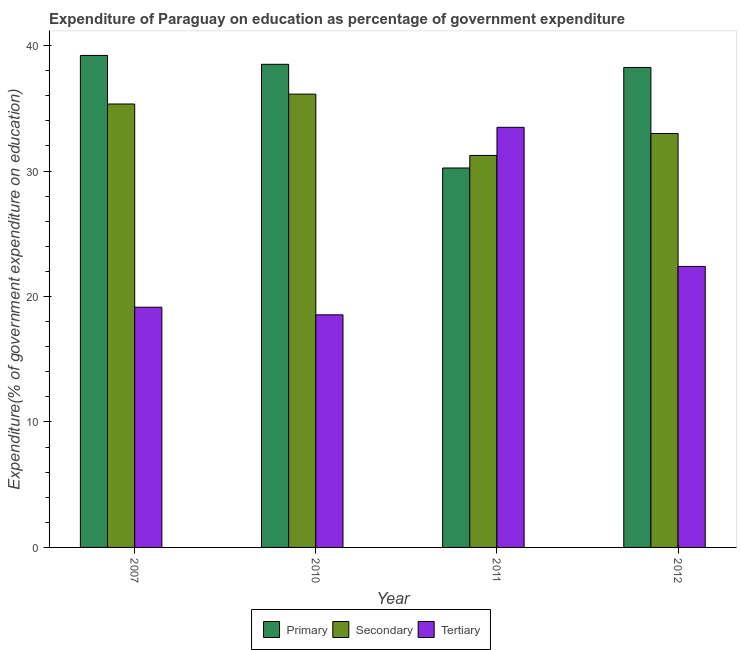How many different coloured bars are there?
Offer a very short reply. 3. Are the number of bars on each tick of the X-axis equal?
Your answer should be compact. Yes. How many bars are there on the 4th tick from the left?
Offer a terse response. 3. How many bars are there on the 4th tick from the right?
Your answer should be very brief. 3. What is the expenditure on primary education in 2011?
Your response must be concise. 30.24. Across all years, what is the maximum expenditure on primary education?
Keep it short and to the point. 39.21. Across all years, what is the minimum expenditure on secondary education?
Your answer should be very brief. 31.24. In which year was the expenditure on tertiary education maximum?
Your response must be concise. 2011. What is the total expenditure on primary education in the graph?
Keep it short and to the point. 146.22. What is the difference between the expenditure on primary education in 2007 and that in 2010?
Your answer should be compact. 0.71. What is the difference between the expenditure on primary education in 2011 and the expenditure on secondary education in 2012?
Your answer should be compact. -8.01. What is the average expenditure on tertiary education per year?
Your response must be concise. 23.39. What is the ratio of the expenditure on secondary education in 2007 to that in 2012?
Offer a terse response. 1.07. What is the difference between the highest and the second highest expenditure on tertiary education?
Provide a succinct answer. 11.09. What is the difference between the highest and the lowest expenditure on tertiary education?
Make the answer very short. 14.95. In how many years, is the expenditure on tertiary education greater than the average expenditure on tertiary education taken over all years?
Offer a terse response. 1. What does the 1st bar from the left in 2007 represents?
Offer a terse response. Primary. What does the 2nd bar from the right in 2007 represents?
Give a very brief answer. Secondary. Is it the case that in every year, the sum of the expenditure on primary education and expenditure on secondary education is greater than the expenditure on tertiary education?
Make the answer very short. Yes. Are all the bars in the graph horizontal?
Ensure brevity in your answer.  No. How many years are there in the graph?
Keep it short and to the point. 4. What is the difference between two consecutive major ticks on the Y-axis?
Your response must be concise. 10. Are the values on the major ticks of Y-axis written in scientific E-notation?
Ensure brevity in your answer.  No. Does the graph contain grids?
Ensure brevity in your answer.  No. Where does the legend appear in the graph?
Your answer should be compact. Bottom center. How many legend labels are there?
Offer a terse response. 3. How are the legend labels stacked?
Your response must be concise. Horizontal. What is the title of the graph?
Offer a terse response. Expenditure of Paraguay on education as percentage of government expenditure. Does "Oil" appear as one of the legend labels in the graph?
Make the answer very short. No. What is the label or title of the Y-axis?
Your answer should be very brief. Expenditure(% of government expenditure on education). What is the Expenditure(% of government expenditure on education) of Primary in 2007?
Offer a very short reply. 39.21. What is the Expenditure(% of government expenditure on education) in Secondary in 2007?
Give a very brief answer. 35.34. What is the Expenditure(% of government expenditure on education) of Tertiary in 2007?
Your response must be concise. 19.15. What is the Expenditure(% of government expenditure on education) of Primary in 2010?
Your answer should be compact. 38.51. What is the Expenditure(% of government expenditure on education) of Secondary in 2010?
Give a very brief answer. 36.13. What is the Expenditure(% of government expenditure on education) of Tertiary in 2010?
Offer a terse response. 18.54. What is the Expenditure(% of government expenditure on education) in Primary in 2011?
Provide a short and direct response. 30.24. What is the Expenditure(% of government expenditure on education) in Secondary in 2011?
Your answer should be very brief. 31.24. What is the Expenditure(% of government expenditure on education) of Tertiary in 2011?
Your answer should be compact. 33.48. What is the Expenditure(% of government expenditure on education) of Primary in 2012?
Keep it short and to the point. 38.25. What is the Expenditure(% of government expenditure on education) of Secondary in 2012?
Make the answer very short. 32.99. What is the Expenditure(% of government expenditure on education) of Tertiary in 2012?
Keep it short and to the point. 22.4. Across all years, what is the maximum Expenditure(% of government expenditure on education) in Primary?
Make the answer very short. 39.21. Across all years, what is the maximum Expenditure(% of government expenditure on education) of Secondary?
Your response must be concise. 36.13. Across all years, what is the maximum Expenditure(% of government expenditure on education) of Tertiary?
Provide a short and direct response. 33.48. Across all years, what is the minimum Expenditure(% of government expenditure on education) of Primary?
Offer a terse response. 30.24. Across all years, what is the minimum Expenditure(% of government expenditure on education) of Secondary?
Provide a short and direct response. 31.24. Across all years, what is the minimum Expenditure(% of government expenditure on education) in Tertiary?
Make the answer very short. 18.54. What is the total Expenditure(% of government expenditure on education) of Primary in the graph?
Make the answer very short. 146.22. What is the total Expenditure(% of government expenditure on education) in Secondary in the graph?
Offer a very short reply. 135.7. What is the total Expenditure(% of government expenditure on education) in Tertiary in the graph?
Ensure brevity in your answer.  93.57. What is the difference between the Expenditure(% of government expenditure on education) in Primary in 2007 and that in 2010?
Ensure brevity in your answer.  0.71. What is the difference between the Expenditure(% of government expenditure on education) in Secondary in 2007 and that in 2010?
Offer a very short reply. -0.79. What is the difference between the Expenditure(% of government expenditure on education) in Tertiary in 2007 and that in 2010?
Your answer should be compact. 0.61. What is the difference between the Expenditure(% of government expenditure on education) in Primary in 2007 and that in 2011?
Give a very brief answer. 8.97. What is the difference between the Expenditure(% of government expenditure on education) in Secondary in 2007 and that in 2011?
Your response must be concise. 4.1. What is the difference between the Expenditure(% of government expenditure on education) in Tertiary in 2007 and that in 2011?
Give a very brief answer. -14.34. What is the difference between the Expenditure(% of government expenditure on education) in Primary in 2007 and that in 2012?
Give a very brief answer. 0.96. What is the difference between the Expenditure(% of government expenditure on education) of Secondary in 2007 and that in 2012?
Offer a very short reply. 2.35. What is the difference between the Expenditure(% of government expenditure on education) of Tertiary in 2007 and that in 2012?
Provide a short and direct response. -3.25. What is the difference between the Expenditure(% of government expenditure on education) in Primary in 2010 and that in 2011?
Ensure brevity in your answer.  8.26. What is the difference between the Expenditure(% of government expenditure on education) in Secondary in 2010 and that in 2011?
Your answer should be compact. 4.89. What is the difference between the Expenditure(% of government expenditure on education) in Tertiary in 2010 and that in 2011?
Offer a terse response. -14.95. What is the difference between the Expenditure(% of government expenditure on education) of Primary in 2010 and that in 2012?
Your response must be concise. 0.25. What is the difference between the Expenditure(% of government expenditure on education) of Secondary in 2010 and that in 2012?
Your answer should be compact. 3.14. What is the difference between the Expenditure(% of government expenditure on education) in Tertiary in 2010 and that in 2012?
Give a very brief answer. -3.86. What is the difference between the Expenditure(% of government expenditure on education) in Primary in 2011 and that in 2012?
Give a very brief answer. -8.01. What is the difference between the Expenditure(% of government expenditure on education) in Secondary in 2011 and that in 2012?
Your answer should be very brief. -1.75. What is the difference between the Expenditure(% of government expenditure on education) in Tertiary in 2011 and that in 2012?
Your response must be concise. 11.09. What is the difference between the Expenditure(% of government expenditure on education) in Primary in 2007 and the Expenditure(% of government expenditure on education) in Secondary in 2010?
Keep it short and to the point. 3.08. What is the difference between the Expenditure(% of government expenditure on education) in Primary in 2007 and the Expenditure(% of government expenditure on education) in Tertiary in 2010?
Keep it short and to the point. 20.68. What is the difference between the Expenditure(% of government expenditure on education) in Secondary in 2007 and the Expenditure(% of government expenditure on education) in Tertiary in 2010?
Your answer should be compact. 16.8. What is the difference between the Expenditure(% of government expenditure on education) of Primary in 2007 and the Expenditure(% of government expenditure on education) of Secondary in 2011?
Provide a succinct answer. 7.97. What is the difference between the Expenditure(% of government expenditure on education) of Primary in 2007 and the Expenditure(% of government expenditure on education) of Tertiary in 2011?
Keep it short and to the point. 5.73. What is the difference between the Expenditure(% of government expenditure on education) in Secondary in 2007 and the Expenditure(% of government expenditure on education) in Tertiary in 2011?
Your answer should be compact. 1.86. What is the difference between the Expenditure(% of government expenditure on education) of Primary in 2007 and the Expenditure(% of government expenditure on education) of Secondary in 2012?
Offer a terse response. 6.22. What is the difference between the Expenditure(% of government expenditure on education) of Primary in 2007 and the Expenditure(% of government expenditure on education) of Tertiary in 2012?
Your answer should be very brief. 16.82. What is the difference between the Expenditure(% of government expenditure on education) in Secondary in 2007 and the Expenditure(% of government expenditure on education) in Tertiary in 2012?
Your response must be concise. 12.94. What is the difference between the Expenditure(% of government expenditure on education) in Primary in 2010 and the Expenditure(% of government expenditure on education) in Secondary in 2011?
Make the answer very short. 7.27. What is the difference between the Expenditure(% of government expenditure on education) of Primary in 2010 and the Expenditure(% of government expenditure on education) of Tertiary in 2011?
Your response must be concise. 5.02. What is the difference between the Expenditure(% of government expenditure on education) in Secondary in 2010 and the Expenditure(% of government expenditure on education) in Tertiary in 2011?
Provide a succinct answer. 2.65. What is the difference between the Expenditure(% of government expenditure on education) of Primary in 2010 and the Expenditure(% of government expenditure on education) of Secondary in 2012?
Provide a short and direct response. 5.51. What is the difference between the Expenditure(% of government expenditure on education) of Primary in 2010 and the Expenditure(% of government expenditure on education) of Tertiary in 2012?
Keep it short and to the point. 16.11. What is the difference between the Expenditure(% of government expenditure on education) in Secondary in 2010 and the Expenditure(% of government expenditure on education) in Tertiary in 2012?
Offer a terse response. 13.73. What is the difference between the Expenditure(% of government expenditure on education) of Primary in 2011 and the Expenditure(% of government expenditure on education) of Secondary in 2012?
Make the answer very short. -2.75. What is the difference between the Expenditure(% of government expenditure on education) of Primary in 2011 and the Expenditure(% of government expenditure on education) of Tertiary in 2012?
Your response must be concise. 7.84. What is the difference between the Expenditure(% of government expenditure on education) of Secondary in 2011 and the Expenditure(% of government expenditure on education) of Tertiary in 2012?
Provide a short and direct response. 8.84. What is the average Expenditure(% of government expenditure on education) in Primary per year?
Offer a very short reply. 36.55. What is the average Expenditure(% of government expenditure on education) in Secondary per year?
Offer a very short reply. 33.93. What is the average Expenditure(% of government expenditure on education) of Tertiary per year?
Give a very brief answer. 23.39. In the year 2007, what is the difference between the Expenditure(% of government expenditure on education) of Primary and Expenditure(% of government expenditure on education) of Secondary?
Ensure brevity in your answer.  3.87. In the year 2007, what is the difference between the Expenditure(% of government expenditure on education) of Primary and Expenditure(% of government expenditure on education) of Tertiary?
Make the answer very short. 20.07. In the year 2007, what is the difference between the Expenditure(% of government expenditure on education) of Secondary and Expenditure(% of government expenditure on education) of Tertiary?
Provide a succinct answer. 16.2. In the year 2010, what is the difference between the Expenditure(% of government expenditure on education) in Primary and Expenditure(% of government expenditure on education) in Secondary?
Your answer should be very brief. 2.38. In the year 2010, what is the difference between the Expenditure(% of government expenditure on education) in Primary and Expenditure(% of government expenditure on education) in Tertiary?
Ensure brevity in your answer.  19.97. In the year 2010, what is the difference between the Expenditure(% of government expenditure on education) in Secondary and Expenditure(% of government expenditure on education) in Tertiary?
Your answer should be very brief. 17.59. In the year 2011, what is the difference between the Expenditure(% of government expenditure on education) in Primary and Expenditure(% of government expenditure on education) in Secondary?
Provide a succinct answer. -1. In the year 2011, what is the difference between the Expenditure(% of government expenditure on education) in Primary and Expenditure(% of government expenditure on education) in Tertiary?
Ensure brevity in your answer.  -3.24. In the year 2011, what is the difference between the Expenditure(% of government expenditure on education) of Secondary and Expenditure(% of government expenditure on education) of Tertiary?
Provide a short and direct response. -2.24. In the year 2012, what is the difference between the Expenditure(% of government expenditure on education) of Primary and Expenditure(% of government expenditure on education) of Secondary?
Provide a short and direct response. 5.26. In the year 2012, what is the difference between the Expenditure(% of government expenditure on education) in Primary and Expenditure(% of government expenditure on education) in Tertiary?
Give a very brief answer. 15.86. In the year 2012, what is the difference between the Expenditure(% of government expenditure on education) in Secondary and Expenditure(% of government expenditure on education) in Tertiary?
Keep it short and to the point. 10.59. What is the ratio of the Expenditure(% of government expenditure on education) of Primary in 2007 to that in 2010?
Your response must be concise. 1.02. What is the ratio of the Expenditure(% of government expenditure on education) in Secondary in 2007 to that in 2010?
Offer a very short reply. 0.98. What is the ratio of the Expenditure(% of government expenditure on education) in Tertiary in 2007 to that in 2010?
Provide a short and direct response. 1.03. What is the ratio of the Expenditure(% of government expenditure on education) in Primary in 2007 to that in 2011?
Offer a terse response. 1.3. What is the ratio of the Expenditure(% of government expenditure on education) of Secondary in 2007 to that in 2011?
Offer a very short reply. 1.13. What is the ratio of the Expenditure(% of government expenditure on education) in Tertiary in 2007 to that in 2011?
Ensure brevity in your answer.  0.57. What is the ratio of the Expenditure(% of government expenditure on education) in Primary in 2007 to that in 2012?
Provide a succinct answer. 1.03. What is the ratio of the Expenditure(% of government expenditure on education) of Secondary in 2007 to that in 2012?
Offer a very short reply. 1.07. What is the ratio of the Expenditure(% of government expenditure on education) in Tertiary in 2007 to that in 2012?
Ensure brevity in your answer.  0.85. What is the ratio of the Expenditure(% of government expenditure on education) of Primary in 2010 to that in 2011?
Offer a terse response. 1.27. What is the ratio of the Expenditure(% of government expenditure on education) in Secondary in 2010 to that in 2011?
Keep it short and to the point. 1.16. What is the ratio of the Expenditure(% of government expenditure on education) in Tertiary in 2010 to that in 2011?
Your answer should be compact. 0.55. What is the ratio of the Expenditure(% of government expenditure on education) in Primary in 2010 to that in 2012?
Keep it short and to the point. 1.01. What is the ratio of the Expenditure(% of government expenditure on education) of Secondary in 2010 to that in 2012?
Keep it short and to the point. 1.1. What is the ratio of the Expenditure(% of government expenditure on education) in Tertiary in 2010 to that in 2012?
Offer a terse response. 0.83. What is the ratio of the Expenditure(% of government expenditure on education) of Primary in 2011 to that in 2012?
Ensure brevity in your answer.  0.79. What is the ratio of the Expenditure(% of government expenditure on education) in Secondary in 2011 to that in 2012?
Your answer should be very brief. 0.95. What is the ratio of the Expenditure(% of government expenditure on education) in Tertiary in 2011 to that in 2012?
Offer a terse response. 1.5. What is the difference between the highest and the second highest Expenditure(% of government expenditure on education) in Primary?
Give a very brief answer. 0.71. What is the difference between the highest and the second highest Expenditure(% of government expenditure on education) in Secondary?
Keep it short and to the point. 0.79. What is the difference between the highest and the second highest Expenditure(% of government expenditure on education) of Tertiary?
Ensure brevity in your answer.  11.09. What is the difference between the highest and the lowest Expenditure(% of government expenditure on education) of Primary?
Offer a very short reply. 8.97. What is the difference between the highest and the lowest Expenditure(% of government expenditure on education) in Secondary?
Provide a short and direct response. 4.89. What is the difference between the highest and the lowest Expenditure(% of government expenditure on education) of Tertiary?
Provide a short and direct response. 14.95. 